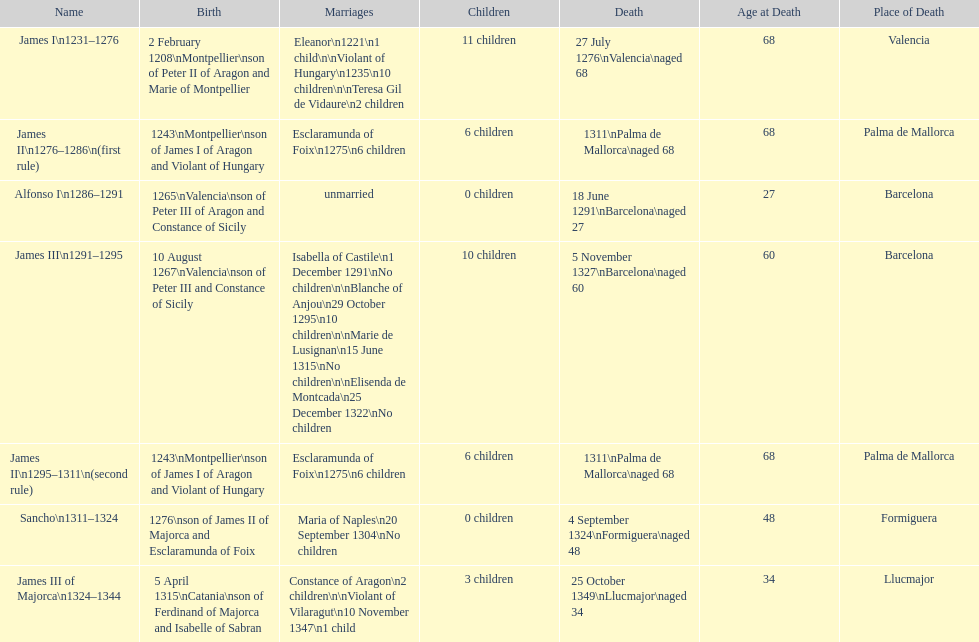How long was james ii in power, including his second rule? 26 years. 